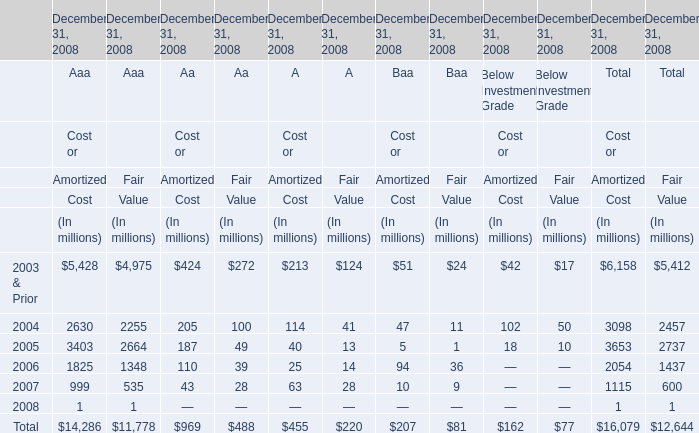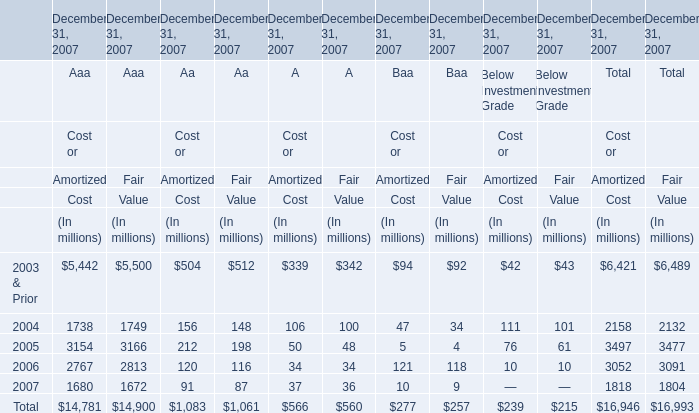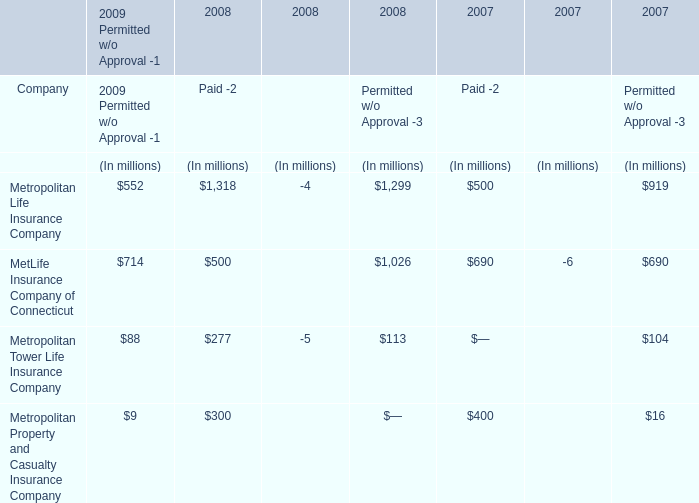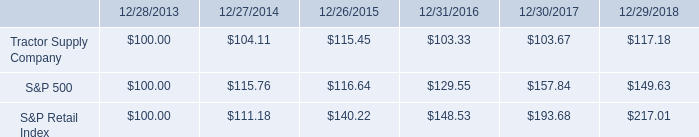how much of a greater return , in percentage , was gained in the s&p retail index compared to the tractor supply company? 
Computations: (((217.01 - 100.00) / 100.00) - ((117.18 - 100) / 100))
Answer: 0.9983. 